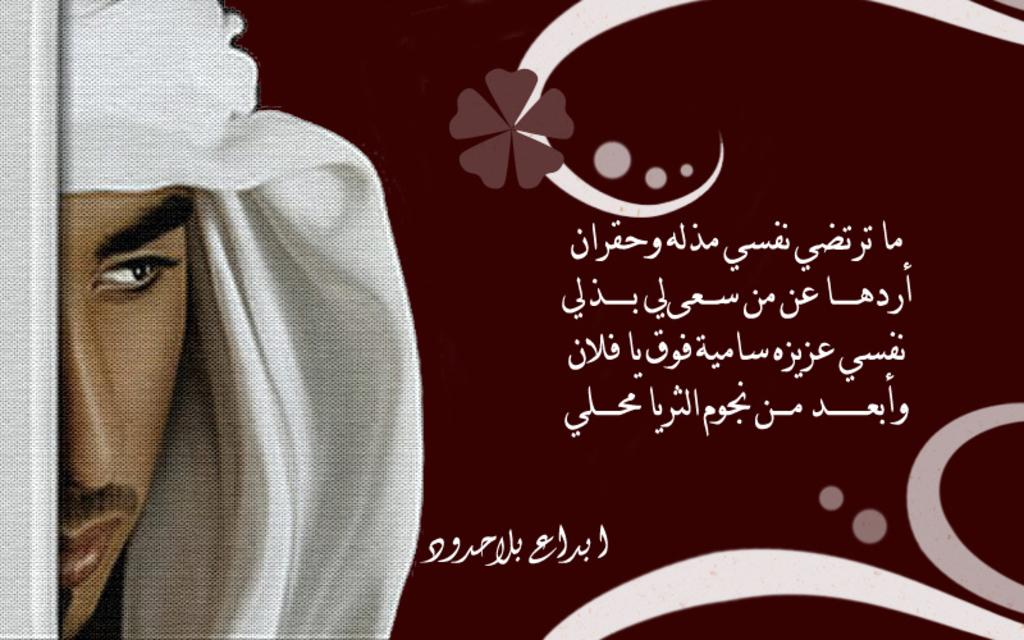What is the main subject of the image? There is a depiction of a man in the image. Are there any words or letters in the image? Yes, there is text written in the image. What color is the background of the image? The background has a brown color. How much credit does the man in the image have? There is no information about credit in the image, as it only depicts a man and some text. Is there any poison visible in the image? There is no mention of poison in the image, and it does not appear to be a relevant topic based on the provided facts. 